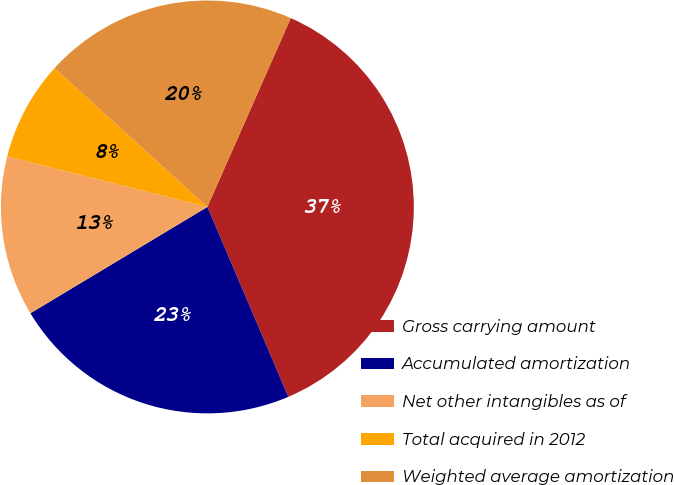<chart> <loc_0><loc_0><loc_500><loc_500><pie_chart><fcel>Gross carrying amount<fcel>Accumulated amortization<fcel>Net other intangibles as of<fcel>Total acquired in 2012<fcel>Weighted average amortization<nl><fcel>36.97%<fcel>22.8%<fcel>12.55%<fcel>7.8%<fcel>19.88%<nl></chart> 